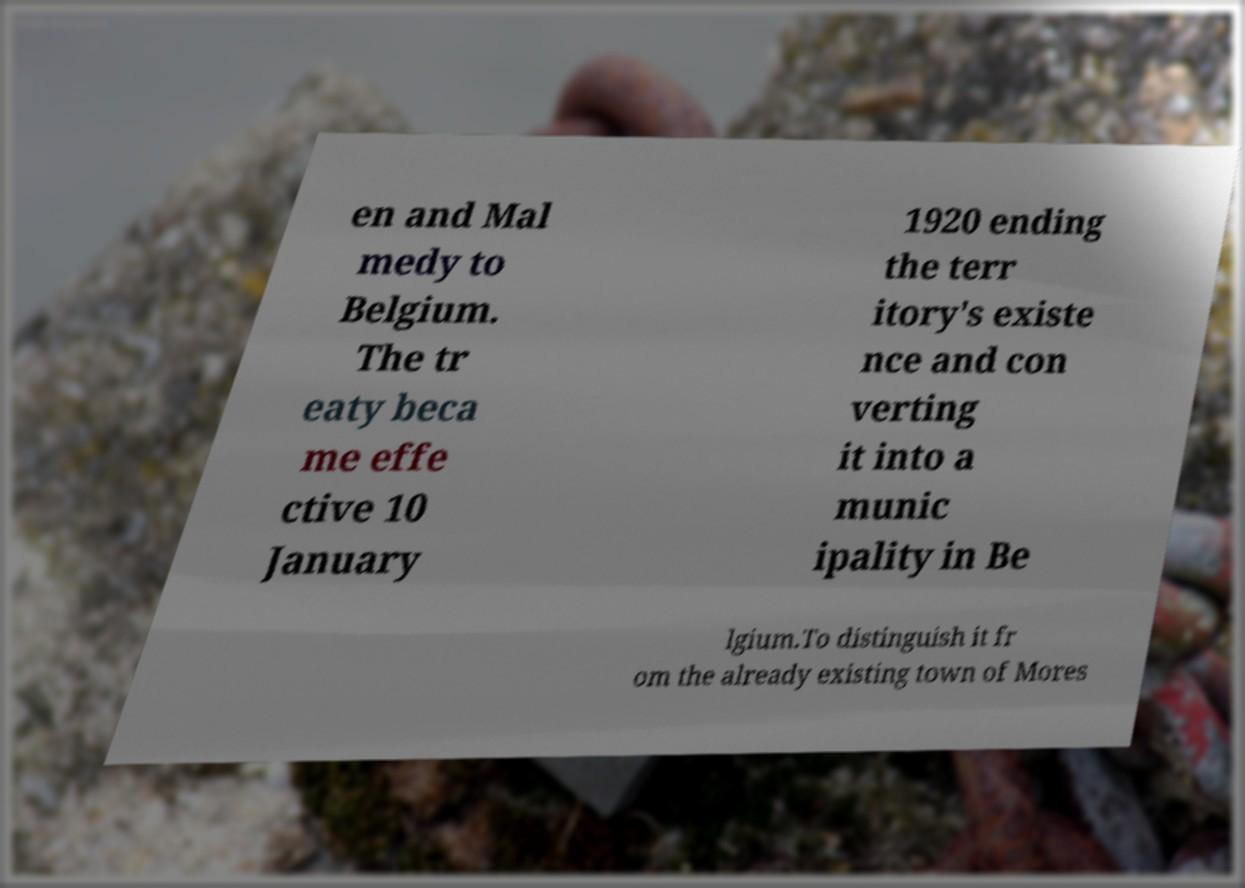There's text embedded in this image that I need extracted. Can you transcribe it verbatim? en and Mal medy to Belgium. The tr eaty beca me effe ctive 10 January 1920 ending the terr itory's existe nce and con verting it into a munic ipality in Be lgium.To distinguish it fr om the already existing town of Mores 